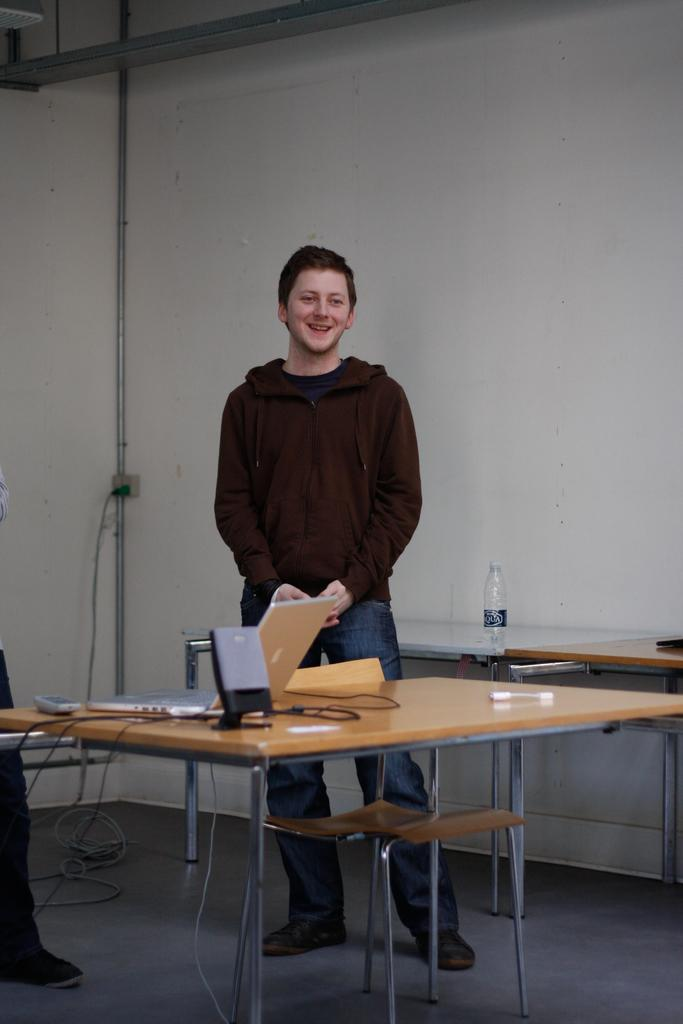What is the main subject of the image? There is a person standing in the center of the image. What is the person doing in the image? The person is smiling. What can be seen on the table in the image? There are objects on a table in the image. What is visible in the background of the image? There is a wall in the background of the image. What type of news is the person reading in the image? There is no news or any reading material visible in the image. How many lizards are crawling on the wall in the background? There are no lizards present in the image; only a wall is visible in the background. 